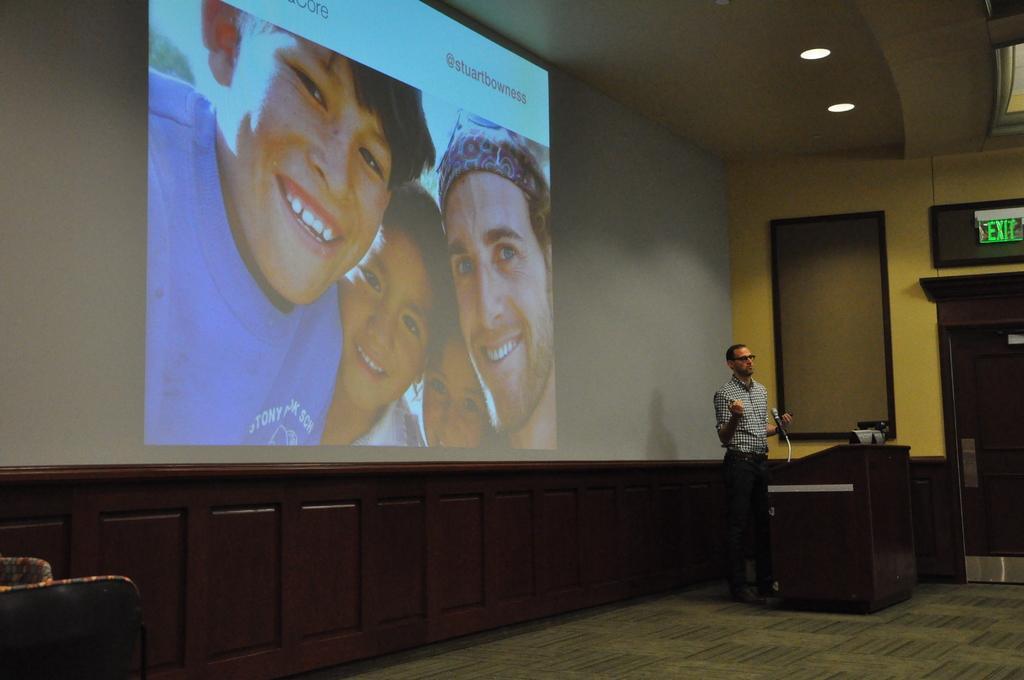How would you summarize this image in a sentence or two? In this image we can see a screen, in this we can see some persons and text, there is a person standing in front of the podium, on the top of the roof there are some lights and on the wall there is a frame and exit board. 